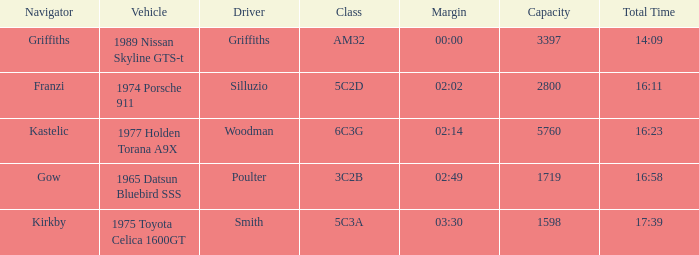What driver had a total time of 16:58? Poulter. 